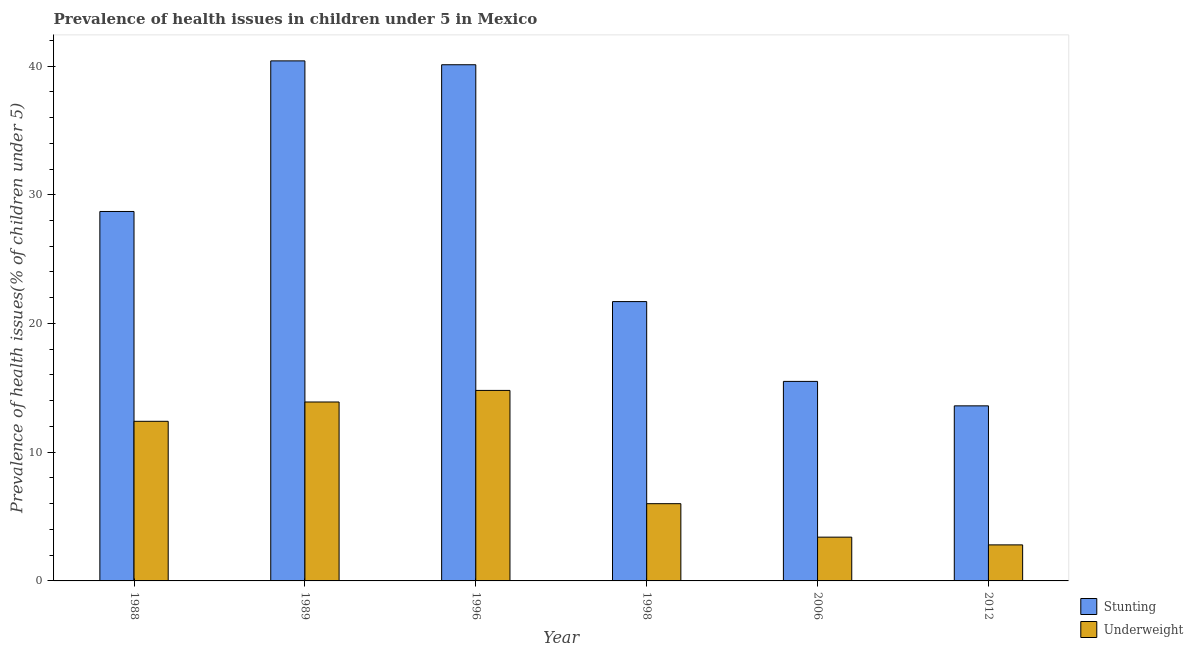How many different coloured bars are there?
Provide a short and direct response. 2. How many groups of bars are there?
Offer a terse response. 6. Are the number of bars per tick equal to the number of legend labels?
Your response must be concise. Yes. Are the number of bars on each tick of the X-axis equal?
Make the answer very short. Yes. What is the label of the 4th group of bars from the left?
Offer a terse response. 1998. What is the percentage of underweight children in 1998?
Give a very brief answer. 6. Across all years, what is the maximum percentage of underweight children?
Make the answer very short. 14.8. Across all years, what is the minimum percentage of stunted children?
Offer a terse response. 13.6. In which year was the percentage of stunted children maximum?
Offer a terse response. 1989. What is the total percentage of underweight children in the graph?
Provide a succinct answer. 53.3. What is the difference between the percentage of stunted children in 1996 and that in 2012?
Keep it short and to the point. 26.5. What is the difference between the percentage of stunted children in 1988 and the percentage of underweight children in 1996?
Your answer should be compact. -11.4. What is the average percentage of underweight children per year?
Keep it short and to the point. 8.88. In the year 2012, what is the difference between the percentage of underweight children and percentage of stunted children?
Keep it short and to the point. 0. In how many years, is the percentage of stunted children greater than 14 %?
Offer a terse response. 5. What is the ratio of the percentage of stunted children in 1996 to that in 2012?
Give a very brief answer. 2.95. Is the percentage of underweight children in 1998 less than that in 2006?
Keep it short and to the point. No. What is the difference between the highest and the second highest percentage of stunted children?
Offer a terse response. 0.3. What is the difference between the highest and the lowest percentage of stunted children?
Offer a terse response. 26.8. In how many years, is the percentage of stunted children greater than the average percentage of stunted children taken over all years?
Offer a very short reply. 3. What does the 2nd bar from the left in 1996 represents?
Provide a short and direct response. Underweight. What does the 1st bar from the right in 2012 represents?
Your answer should be very brief. Underweight. How many years are there in the graph?
Make the answer very short. 6. What is the difference between two consecutive major ticks on the Y-axis?
Ensure brevity in your answer.  10. Are the values on the major ticks of Y-axis written in scientific E-notation?
Provide a short and direct response. No. Does the graph contain any zero values?
Offer a terse response. No. Does the graph contain grids?
Make the answer very short. No. Where does the legend appear in the graph?
Your answer should be very brief. Bottom right. What is the title of the graph?
Make the answer very short. Prevalence of health issues in children under 5 in Mexico. What is the label or title of the X-axis?
Your answer should be compact. Year. What is the label or title of the Y-axis?
Make the answer very short. Prevalence of health issues(% of children under 5). What is the Prevalence of health issues(% of children under 5) of Stunting in 1988?
Ensure brevity in your answer.  28.7. What is the Prevalence of health issues(% of children under 5) in Underweight in 1988?
Your answer should be compact. 12.4. What is the Prevalence of health issues(% of children under 5) in Stunting in 1989?
Keep it short and to the point. 40.4. What is the Prevalence of health issues(% of children under 5) of Underweight in 1989?
Provide a succinct answer. 13.9. What is the Prevalence of health issues(% of children under 5) in Stunting in 1996?
Your answer should be compact. 40.1. What is the Prevalence of health issues(% of children under 5) of Underweight in 1996?
Keep it short and to the point. 14.8. What is the Prevalence of health issues(% of children under 5) of Stunting in 1998?
Give a very brief answer. 21.7. What is the Prevalence of health issues(% of children under 5) in Underweight in 2006?
Offer a very short reply. 3.4. What is the Prevalence of health issues(% of children under 5) in Stunting in 2012?
Make the answer very short. 13.6. What is the Prevalence of health issues(% of children under 5) in Underweight in 2012?
Ensure brevity in your answer.  2.8. Across all years, what is the maximum Prevalence of health issues(% of children under 5) of Stunting?
Give a very brief answer. 40.4. Across all years, what is the maximum Prevalence of health issues(% of children under 5) of Underweight?
Offer a terse response. 14.8. Across all years, what is the minimum Prevalence of health issues(% of children under 5) in Stunting?
Make the answer very short. 13.6. Across all years, what is the minimum Prevalence of health issues(% of children under 5) of Underweight?
Give a very brief answer. 2.8. What is the total Prevalence of health issues(% of children under 5) of Stunting in the graph?
Make the answer very short. 160. What is the total Prevalence of health issues(% of children under 5) in Underweight in the graph?
Provide a succinct answer. 53.3. What is the difference between the Prevalence of health issues(% of children under 5) of Stunting in 1988 and that in 1989?
Provide a succinct answer. -11.7. What is the difference between the Prevalence of health issues(% of children under 5) in Underweight in 1988 and that in 1989?
Give a very brief answer. -1.5. What is the difference between the Prevalence of health issues(% of children under 5) of Stunting in 1988 and that in 1998?
Keep it short and to the point. 7. What is the difference between the Prevalence of health issues(% of children under 5) of Underweight in 1988 and that in 1998?
Keep it short and to the point. 6.4. What is the difference between the Prevalence of health issues(% of children under 5) in Stunting in 1988 and that in 2006?
Your answer should be very brief. 13.2. What is the difference between the Prevalence of health issues(% of children under 5) in Underweight in 1989 and that in 1996?
Your response must be concise. -0.9. What is the difference between the Prevalence of health issues(% of children under 5) in Underweight in 1989 and that in 1998?
Offer a terse response. 7.9. What is the difference between the Prevalence of health issues(% of children under 5) in Stunting in 1989 and that in 2006?
Your answer should be compact. 24.9. What is the difference between the Prevalence of health issues(% of children under 5) in Stunting in 1989 and that in 2012?
Give a very brief answer. 26.8. What is the difference between the Prevalence of health issues(% of children under 5) of Underweight in 1989 and that in 2012?
Keep it short and to the point. 11.1. What is the difference between the Prevalence of health issues(% of children under 5) of Underweight in 1996 and that in 1998?
Your response must be concise. 8.8. What is the difference between the Prevalence of health issues(% of children under 5) in Stunting in 1996 and that in 2006?
Your answer should be compact. 24.6. What is the difference between the Prevalence of health issues(% of children under 5) of Underweight in 1996 and that in 2006?
Offer a terse response. 11.4. What is the difference between the Prevalence of health issues(% of children under 5) of Stunting in 1996 and that in 2012?
Your answer should be very brief. 26.5. What is the difference between the Prevalence of health issues(% of children under 5) of Underweight in 1996 and that in 2012?
Keep it short and to the point. 12. What is the difference between the Prevalence of health issues(% of children under 5) of Stunting in 1998 and that in 2006?
Give a very brief answer. 6.2. What is the difference between the Prevalence of health issues(% of children under 5) of Underweight in 1998 and that in 2006?
Your answer should be compact. 2.6. What is the difference between the Prevalence of health issues(% of children under 5) in Underweight in 1998 and that in 2012?
Provide a short and direct response. 3.2. What is the difference between the Prevalence of health issues(% of children under 5) of Stunting in 1988 and the Prevalence of health issues(% of children under 5) of Underweight in 1996?
Provide a succinct answer. 13.9. What is the difference between the Prevalence of health issues(% of children under 5) of Stunting in 1988 and the Prevalence of health issues(% of children under 5) of Underweight in 1998?
Offer a very short reply. 22.7. What is the difference between the Prevalence of health issues(% of children under 5) of Stunting in 1988 and the Prevalence of health issues(% of children under 5) of Underweight in 2006?
Your answer should be compact. 25.3. What is the difference between the Prevalence of health issues(% of children under 5) in Stunting in 1988 and the Prevalence of health issues(% of children under 5) in Underweight in 2012?
Offer a terse response. 25.9. What is the difference between the Prevalence of health issues(% of children under 5) of Stunting in 1989 and the Prevalence of health issues(% of children under 5) of Underweight in 1996?
Your response must be concise. 25.6. What is the difference between the Prevalence of health issues(% of children under 5) of Stunting in 1989 and the Prevalence of health issues(% of children under 5) of Underweight in 1998?
Offer a terse response. 34.4. What is the difference between the Prevalence of health issues(% of children under 5) in Stunting in 1989 and the Prevalence of health issues(% of children under 5) in Underweight in 2012?
Provide a short and direct response. 37.6. What is the difference between the Prevalence of health issues(% of children under 5) in Stunting in 1996 and the Prevalence of health issues(% of children under 5) in Underweight in 1998?
Ensure brevity in your answer.  34.1. What is the difference between the Prevalence of health issues(% of children under 5) in Stunting in 1996 and the Prevalence of health issues(% of children under 5) in Underweight in 2006?
Offer a very short reply. 36.7. What is the difference between the Prevalence of health issues(% of children under 5) of Stunting in 1996 and the Prevalence of health issues(% of children under 5) of Underweight in 2012?
Your response must be concise. 37.3. What is the difference between the Prevalence of health issues(% of children under 5) of Stunting in 2006 and the Prevalence of health issues(% of children under 5) of Underweight in 2012?
Provide a short and direct response. 12.7. What is the average Prevalence of health issues(% of children under 5) in Stunting per year?
Make the answer very short. 26.67. What is the average Prevalence of health issues(% of children under 5) in Underweight per year?
Give a very brief answer. 8.88. In the year 1989, what is the difference between the Prevalence of health issues(% of children under 5) in Stunting and Prevalence of health issues(% of children under 5) in Underweight?
Provide a short and direct response. 26.5. In the year 1996, what is the difference between the Prevalence of health issues(% of children under 5) of Stunting and Prevalence of health issues(% of children under 5) of Underweight?
Provide a short and direct response. 25.3. In the year 1998, what is the difference between the Prevalence of health issues(% of children under 5) of Stunting and Prevalence of health issues(% of children under 5) of Underweight?
Give a very brief answer. 15.7. In the year 2006, what is the difference between the Prevalence of health issues(% of children under 5) of Stunting and Prevalence of health issues(% of children under 5) of Underweight?
Give a very brief answer. 12.1. What is the ratio of the Prevalence of health issues(% of children under 5) of Stunting in 1988 to that in 1989?
Ensure brevity in your answer.  0.71. What is the ratio of the Prevalence of health issues(% of children under 5) in Underweight in 1988 to that in 1989?
Offer a very short reply. 0.89. What is the ratio of the Prevalence of health issues(% of children under 5) in Stunting in 1988 to that in 1996?
Give a very brief answer. 0.72. What is the ratio of the Prevalence of health issues(% of children under 5) in Underweight in 1988 to that in 1996?
Offer a very short reply. 0.84. What is the ratio of the Prevalence of health issues(% of children under 5) in Stunting in 1988 to that in 1998?
Your answer should be very brief. 1.32. What is the ratio of the Prevalence of health issues(% of children under 5) of Underweight in 1988 to that in 1998?
Ensure brevity in your answer.  2.07. What is the ratio of the Prevalence of health issues(% of children under 5) of Stunting in 1988 to that in 2006?
Offer a very short reply. 1.85. What is the ratio of the Prevalence of health issues(% of children under 5) in Underweight in 1988 to that in 2006?
Give a very brief answer. 3.65. What is the ratio of the Prevalence of health issues(% of children under 5) in Stunting in 1988 to that in 2012?
Make the answer very short. 2.11. What is the ratio of the Prevalence of health issues(% of children under 5) of Underweight in 1988 to that in 2012?
Your answer should be compact. 4.43. What is the ratio of the Prevalence of health issues(% of children under 5) in Stunting in 1989 to that in 1996?
Give a very brief answer. 1.01. What is the ratio of the Prevalence of health issues(% of children under 5) in Underweight in 1989 to that in 1996?
Keep it short and to the point. 0.94. What is the ratio of the Prevalence of health issues(% of children under 5) in Stunting in 1989 to that in 1998?
Keep it short and to the point. 1.86. What is the ratio of the Prevalence of health issues(% of children under 5) of Underweight in 1989 to that in 1998?
Offer a terse response. 2.32. What is the ratio of the Prevalence of health issues(% of children under 5) in Stunting in 1989 to that in 2006?
Ensure brevity in your answer.  2.61. What is the ratio of the Prevalence of health issues(% of children under 5) of Underweight in 1989 to that in 2006?
Keep it short and to the point. 4.09. What is the ratio of the Prevalence of health issues(% of children under 5) in Stunting in 1989 to that in 2012?
Make the answer very short. 2.97. What is the ratio of the Prevalence of health issues(% of children under 5) in Underweight in 1989 to that in 2012?
Ensure brevity in your answer.  4.96. What is the ratio of the Prevalence of health issues(% of children under 5) of Stunting in 1996 to that in 1998?
Offer a terse response. 1.85. What is the ratio of the Prevalence of health issues(% of children under 5) in Underweight in 1996 to that in 1998?
Keep it short and to the point. 2.47. What is the ratio of the Prevalence of health issues(% of children under 5) of Stunting in 1996 to that in 2006?
Provide a short and direct response. 2.59. What is the ratio of the Prevalence of health issues(% of children under 5) of Underweight in 1996 to that in 2006?
Your response must be concise. 4.35. What is the ratio of the Prevalence of health issues(% of children under 5) in Stunting in 1996 to that in 2012?
Give a very brief answer. 2.95. What is the ratio of the Prevalence of health issues(% of children under 5) of Underweight in 1996 to that in 2012?
Your answer should be very brief. 5.29. What is the ratio of the Prevalence of health issues(% of children under 5) of Stunting in 1998 to that in 2006?
Give a very brief answer. 1.4. What is the ratio of the Prevalence of health issues(% of children under 5) in Underweight in 1998 to that in 2006?
Ensure brevity in your answer.  1.76. What is the ratio of the Prevalence of health issues(% of children under 5) in Stunting in 1998 to that in 2012?
Give a very brief answer. 1.6. What is the ratio of the Prevalence of health issues(% of children under 5) in Underweight in 1998 to that in 2012?
Your answer should be very brief. 2.14. What is the ratio of the Prevalence of health issues(% of children under 5) in Stunting in 2006 to that in 2012?
Make the answer very short. 1.14. What is the ratio of the Prevalence of health issues(% of children under 5) in Underweight in 2006 to that in 2012?
Offer a very short reply. 1.21. What is the difference between the highest and the second highest Prevalence of health issues(% of children under 5) of Stunting?
Offer a terse response. 0.3. What is the difference between the highest and the second highest Prevalence of health issues(% of children under 5) in Underweight?
Give a very brief answer. 0.9. What is the difference between the highest and the lowest Prevalence of health issues(% of children under 5) of Stunting?
Ensure brevity in your answer.  26.8. What is the difference between the highest and the lowest Prevalence of health issues(% of children under 5) of Underweight?
Ensure brevity in your answer.  12. 